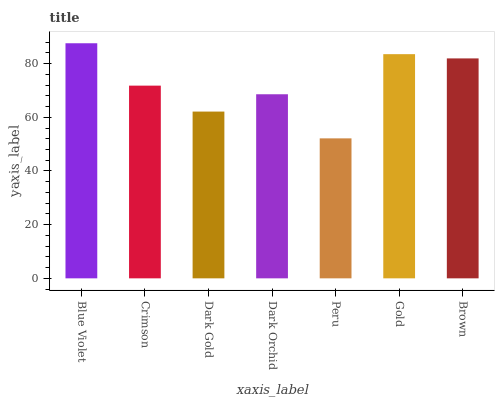Is Peru the minimum?
Answer yes or no. Yes. Is Blue Violet the maximum?
Answer yes or no. Yes. Is Crimson the minimum?
Answer yes or no. No. Is Crimson the maximum?
Answer yes or no. No. Is Blue Violet greater than Crimson?
Answer yes or no. Yes. Is Crimson less than Blue Violet?
Answer yes or no. Yes. Is Crimson greater than Blue Violet?
Answer yes or no. No. Is Blue Violet less than Crimson?
Answer yes or no. No. Is Crimson the high median?
Answer yes or no. Yes. Is Crimson the low median?
Answer yes or no. Yes. Is Peru the high median?
Answer yes or no. No. Is Dark Orchid the low median?
Answer yes or no. No. 